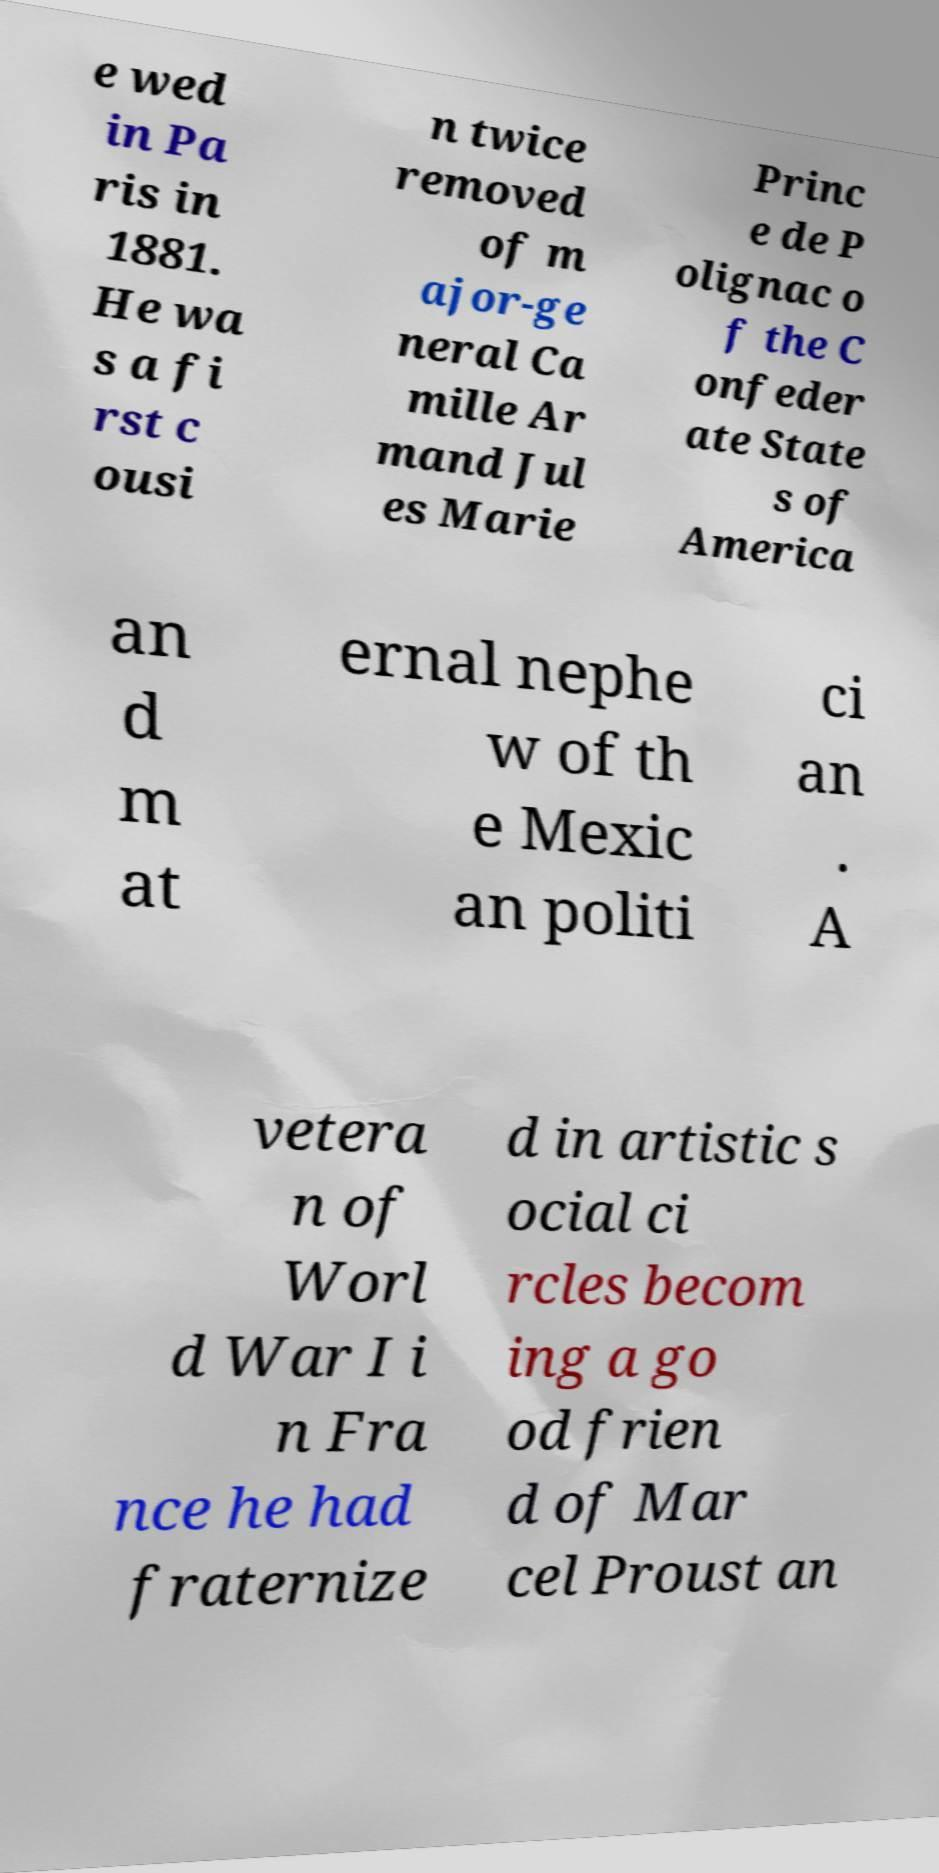Could you assist in decoding the text presented in this image and type it out clearly? e wed in Pa ris in 1881. He wa s a fi rst c ousi n twice removed of m ajor-ge neral Ca mille Ar mand Jul es Marie Princ e de P olignac o f the C onfeder ate State s of America an d m at ernal nephe w of th e Mexic an politi ci an . A vetera n of Worl d War I i n Fra nce he had fraternize d in artistic s ocial ci rcles becom ing a go od frien d of Mar cel Proust an 